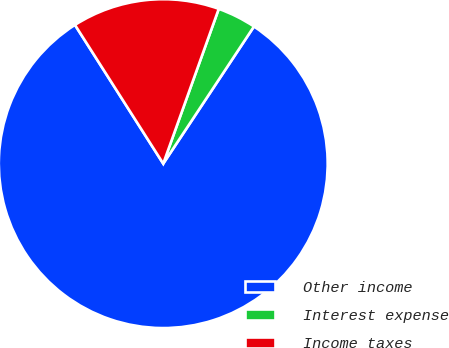Convert chart to OTSL. <chart><loc_0><loc_0><loc_500><loc_500><pie_chart><fcel>Other income<fcel>Interest expense<fcel>Income taxes<nl><fcel>81.68%<fcel>3.82%<fcel>14.5%<nl></chart> 